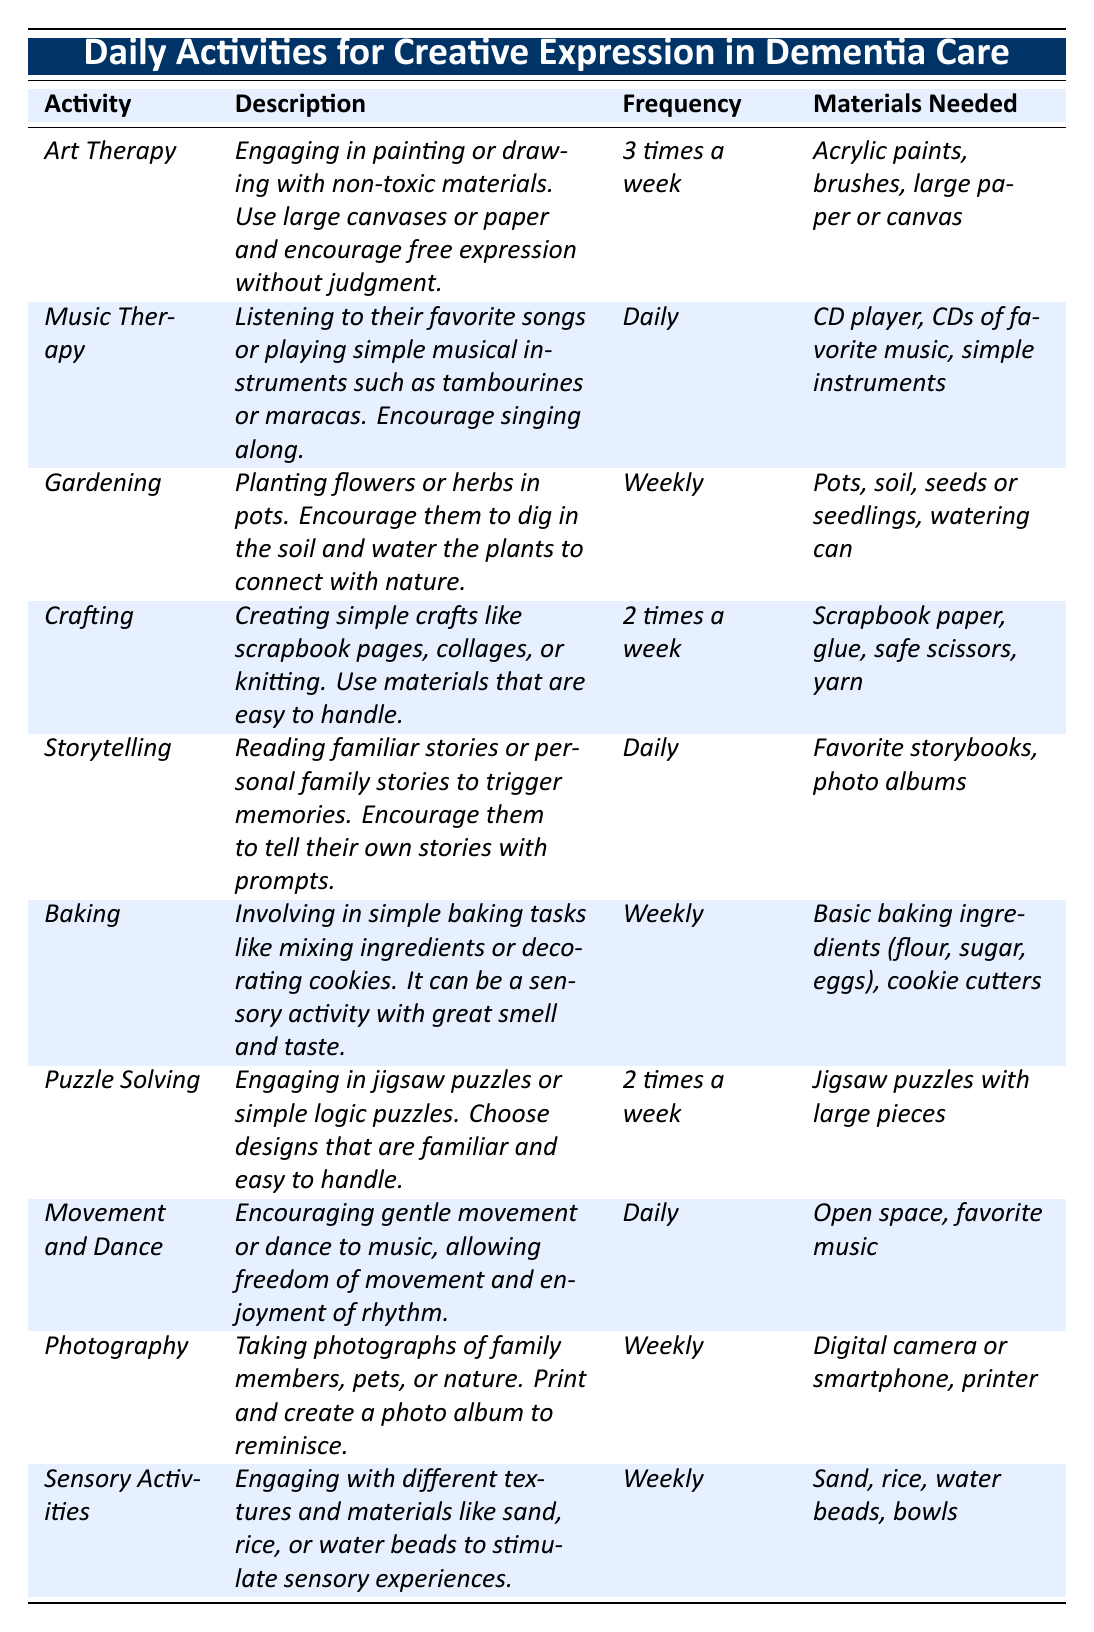What activity is scheduled for daily engagement? The table lists "Music Therapy," "Storytelling," and "Movement and Dance" as activities that occur daily.
Answer: Music Therapy, Storytelling, Movement and Dance How many times a week is "Crafting" suggested? Referring to the table, "Crafting" is listed with a frequency of 2 times a week.
Answer: 2 times a week Which activity requires a digital camera or smartphone? Looking at the materials needed for each activity, "Photography" is the one that requires a digital camera or smartphone.
Answer: Photography Is "Baking" an activity that can be done daily? The table shows that "Baking" has a frequency of weekly, indicating it is not a daily activity. Thus, the answer is no.
Answer: No What is the total number of activities listed in the table? By counting the distinct activities provided in the table, there are 10 activities in total.
Answer: 10 Which activity has the longest frequency interval? The activities occur a maximum of 7 times in a week (daily) and a minimum of 1 time (weekly). "Gardening," "Baking," "Photography," and "Sensory Activities" occur weekly, while "Music Therapy," "Storytelling," and "Movement and Dance" occur daily. Thus, the weekly interval is longer, meaning those four are the correct activities.
Answer: Gardening, Baking, Photography, Sensory Activities What materials are required for "Puzzle Solving"? The table specifies "Jigsaw puzzles with large pieces" as the materials needed for "Puzzle Solving."
Answer: Jigsaw puzzles with large pieces How many activities can be done with equipment that enhances sensory experience? The table features two activities involving sensory experiences: "Baking" and "Sensory Activities." Baking engages with smell and taste, while Sensory Activities focus on textures.
Answer: 2 If you combine the frequencies of "Art Therapy" and "Crafting," how many times a week do those activities occur together? "Art Therapy" occurs 3 times a week and "Crafting" occurs 2 times a week. Adding them results in 3 + 2 = 5 times a week.
Answer: 5 times a week Are there any activities focusing on storytelling? Yes, "Storytelling" is specifically mentioned in the table as an activity focused on reading familiar stories or personal family stories.
Answer: Yes 